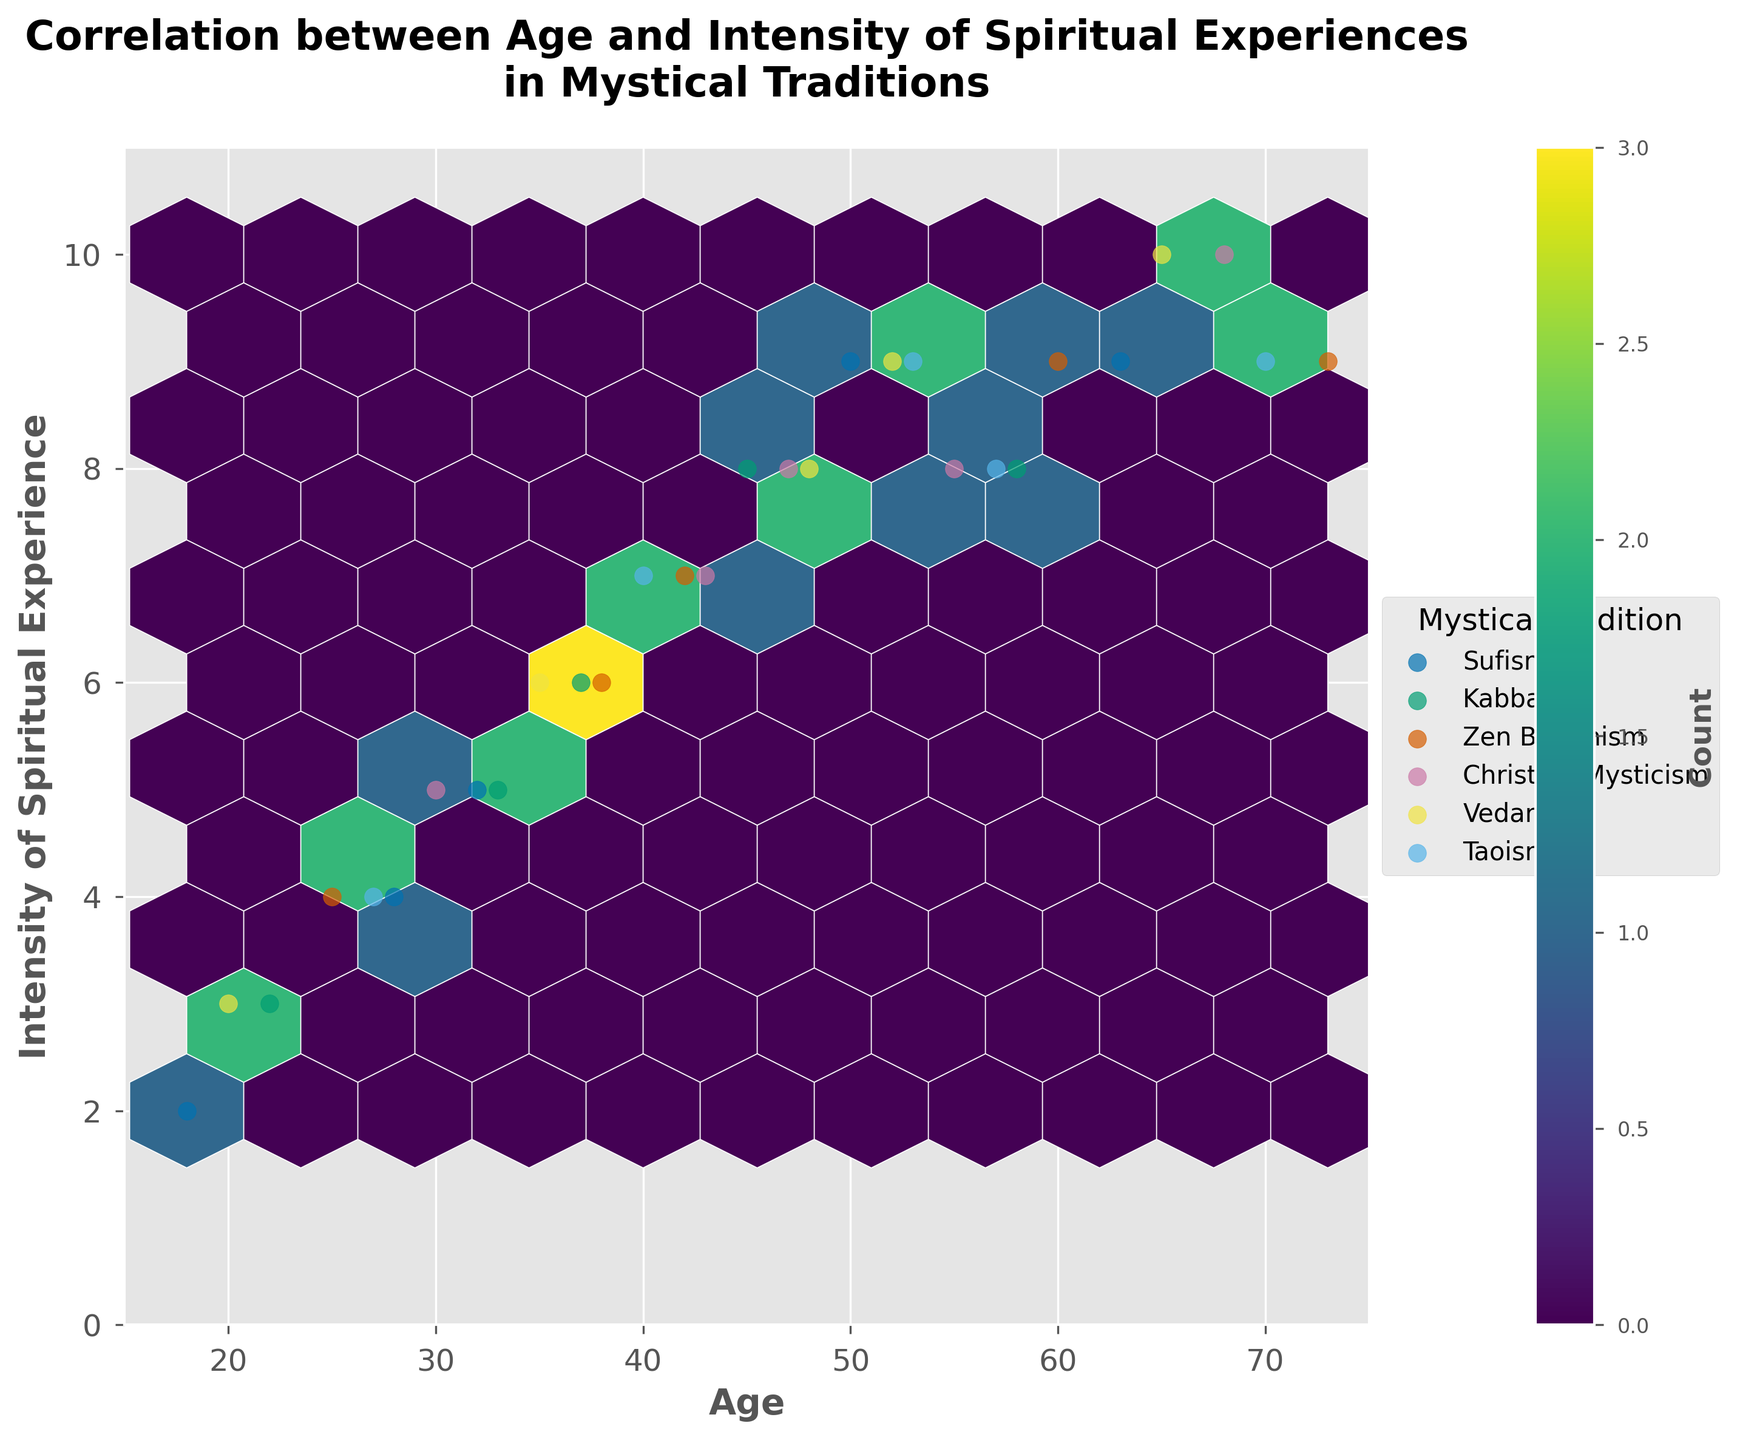What does the title of the figure indicate? The title "Correlation between Age and Intensity of Spiritual Experiences in Mystical Traditions" suggests that the plot is examining the relationship between age and the self-reported intensity of spiritual experiences across different mystical traditions. The key elements are 'Age' and 'Intensity of Spiritual Experience'.
Answer: Correlation between Age and Intensity of Spiritual Experiences in Mystical Traditions What does the color intensity within the hexagons represent? The color intensity within each hexagon indicates the count of data points within that hexagonal bin. Darker hexagons represent higher density or more data points. Lighter hexagons indicate fewer data points.
Answer: Count of data points What is the age range covered in the plot? The x-axis, labeled 'Age', spans from 15 to 75, as indicated by the axis limits set on the plot. Thus, the range of ages covered is from 15 to 75 years.
Answer: 15 to 75 Can you describe the trend between age and intensity of spiritual experiences found in the plot? By visually analyzing the hexbin plot, a positive trend can be observed where the intensity of spiritual experiences tends to increase as age increases. Most of the darker (high-density) hexagons show a pattern where higher intensities are associated with older age groups.
Answer: Intensity increases with age Which tradition has a data point with the highest reported intensity of spiritual experience, and what is the age of that participant? Examining the scatter plot overlaid on the hexbin plot, a data point with an intensity value of 10 is labeled as belonging to the Vedanta tradition, represented by the darker hexagon. The participant's age is 65 years.
Answer: Vedanta, 65 years How many different mystical traditions are represented in the plot? The plot's legend, which categorizes data points by tradition, lists six unique mystical traditions: Sufism, Kabbalah, Zen Buddhism, Christian Mysticism, Vedanta, and Taoism.
Answer: Six What is the average intensity of spiritual experiences for the age group 40-50? To find the average, locate the data points for ages 40, 43, 47, and 48, with intensities 7, 7, 8, and 8 respectively. Calculate the average by summing these intensities (7 + 7 + 8 + 8 = 30) and dividing by the number of data points (4).
Answer: 7.5 Which age group has the most spread of intensity values? Observing the hexbin plot and scatter points, the age group around 60-70 seems to show the greatest spread in the intensity of spiritual experiences, varying from 9 to 10. This broad range indicates a wider distribution compared to other age groups.
Answer: 60-70 Which mystical tradition is most frequently reported among participants aged 50 and above? By visually inspecting the scatter points for participants aged 50 and above and referring to the legend, Zen Buddhism, and Taoism consistently appear. However, Zen Buddhism has the most frequent occurrences.
Answer: Zen Buddhism 